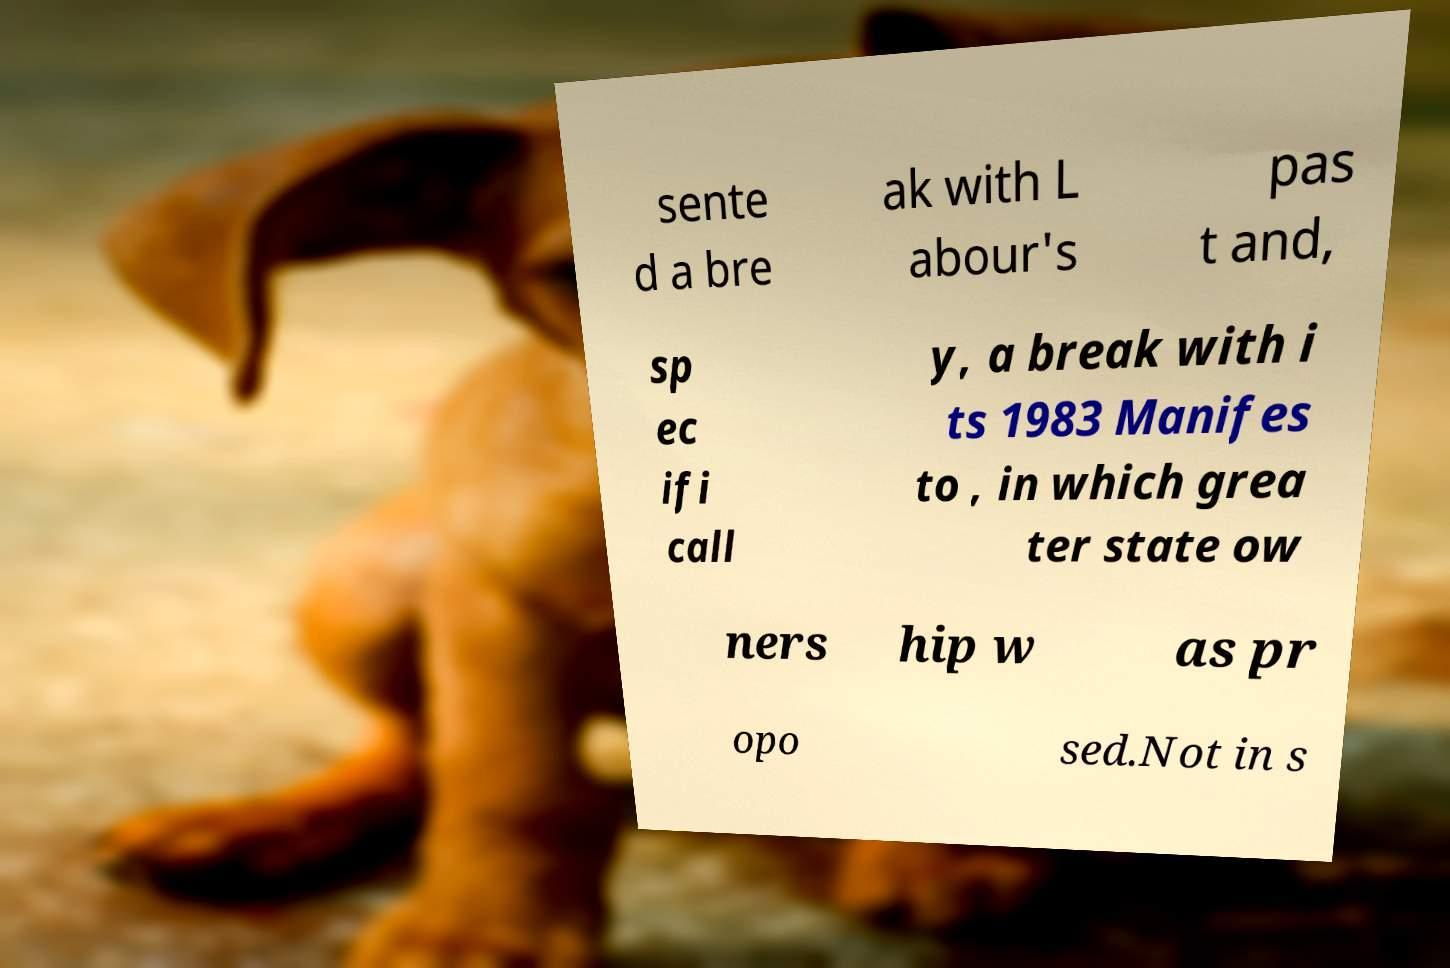I need the written content from this picture converted into text. Can you do that? sente d a bre ak with L abour's pas t and, sp ec ifi call y, a break with i ts 1983 Manifes to , in which grea ter state ow ners hip w as pr opo sed.Not in s 